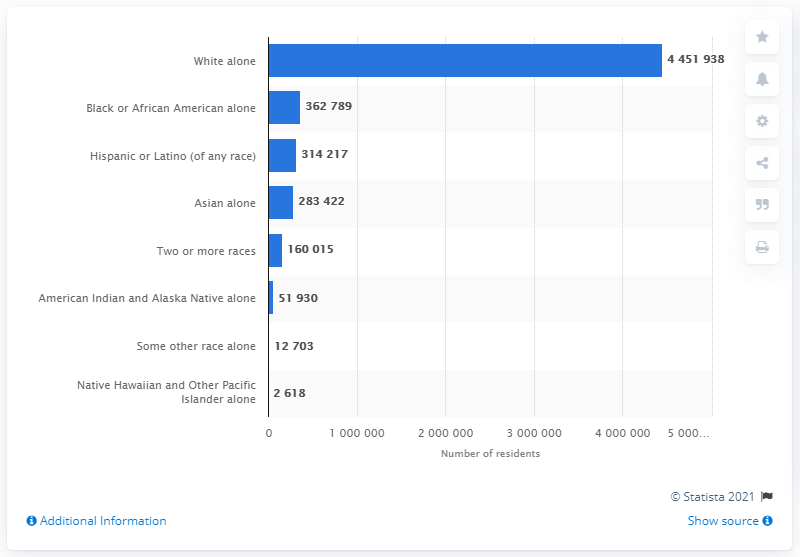Give some essential details in this illustration. In 2019, the state of Minnesota was home to 4,451,938 white residents. 